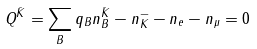Convert formula to latex. <formula><loc_0><loc_0><loc_500><loc_500>Q ^ { \bar { K } } = \sum _ { B } q _ { B } n _ { B } ^ { \bar { K } } - n _ { K } ^ { - } - n _ { e } - n _ { \mu } = 0</formula> 